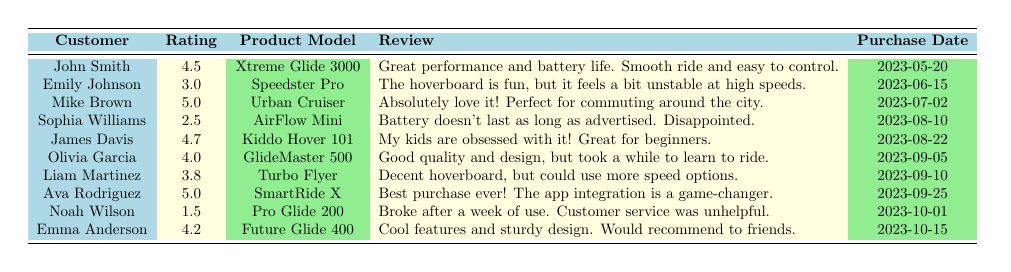What is the highest rating given by a customer? The highest rating in the table is found by comparing all the individual ratings. Mike Brown and Ava Rodriguez both rated their hoverboards 5.0, which is the highest score.
Answer: 5.0 Which product has the lowest rating? To find the product with the lowest rating, we need to scan down the rating column and identify the smallest value. Noah Wilson rated the Pro Glide 200 at 1.5, which is the lowest.
Answer: Pro Glide 200 How many reviews have a rating of 4.0 or higher? We count all ratings that are 4.0 or more in the table. The ratings of 4.5, 5.0, 4.7, 4.0, and 4.2 add up to five reviews.
Answer: 5 What is the average customer rating for all products listed? To calculate the average, we sum all ratings: (4.5 + 3.0 + 5.0 + 2.5 + 4.7 + 4.0 + 3.8 + 5.0 + 1.5 + 4.2) = 3.82. Next, we divide by the total number of reviews (10): 39/10 = 3.9.
Answer: 3.9 Is there a customer review that mentions issues with battery life? We can search through the reviews for any mention of battery-related issues. Both Sophia Williams and John Smith comment on battery life, with Sophia noting a dissatisfaction.
Answer: Yes Which hoverboard model received the highest rating and who reviewed it? The highest rating is 5.0 given by Mike Brown for the Urban Cruiser and also by Ava Rodriguez for the SmartRide X. Hence, both models are included.
Answer: Urban Cruiser and SmartRide X What percentage of customers gave a rating below 3.0? We count how many ratings are below 3.0, which is 1 (Noah Wilson). There are 10 reviews in total, thus the percentage is (1/10) * 100 = 10%.
Answer: 10% What can we infer about family-friendly hoverboards based on ratings? By examining ratings, the Kiddo Hover 101 by James Davis received a high rating of 4.7, indicating it’s rated well for kids. In contrast, the AirFlow Mini has a lower rating of 2.5, suggesting family preferences may vary.
Answer: Mixed results How many customers were disappointed with their purchase? We look for reviews reflecting disappointment. Sophia Williams (2.5 rating) mentions disappointment and Noah Wilson (1.5) explicitly states unhelpful customer service experiences, totaling two.
Answer: 2 